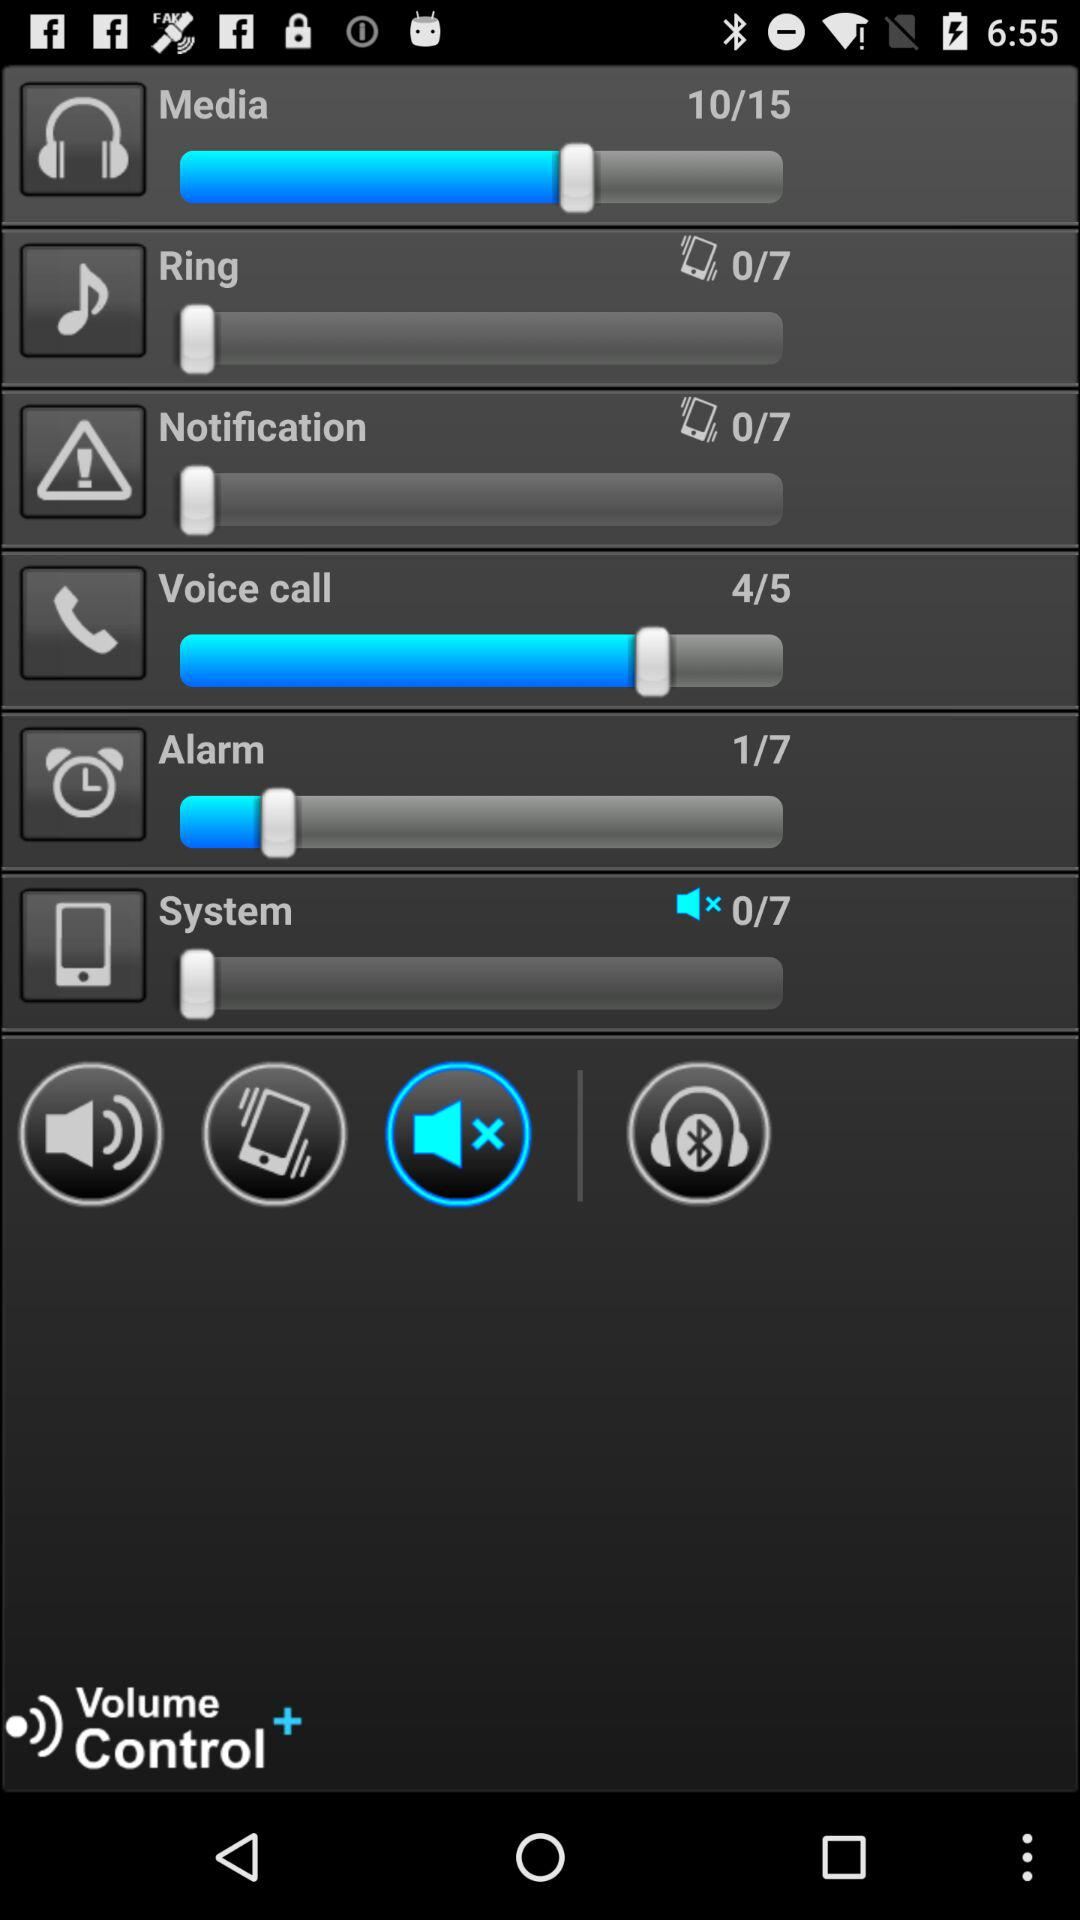What is the selected number of the alarm?
When the provided information is insufficient, respond with <no answer>. <no answer> 